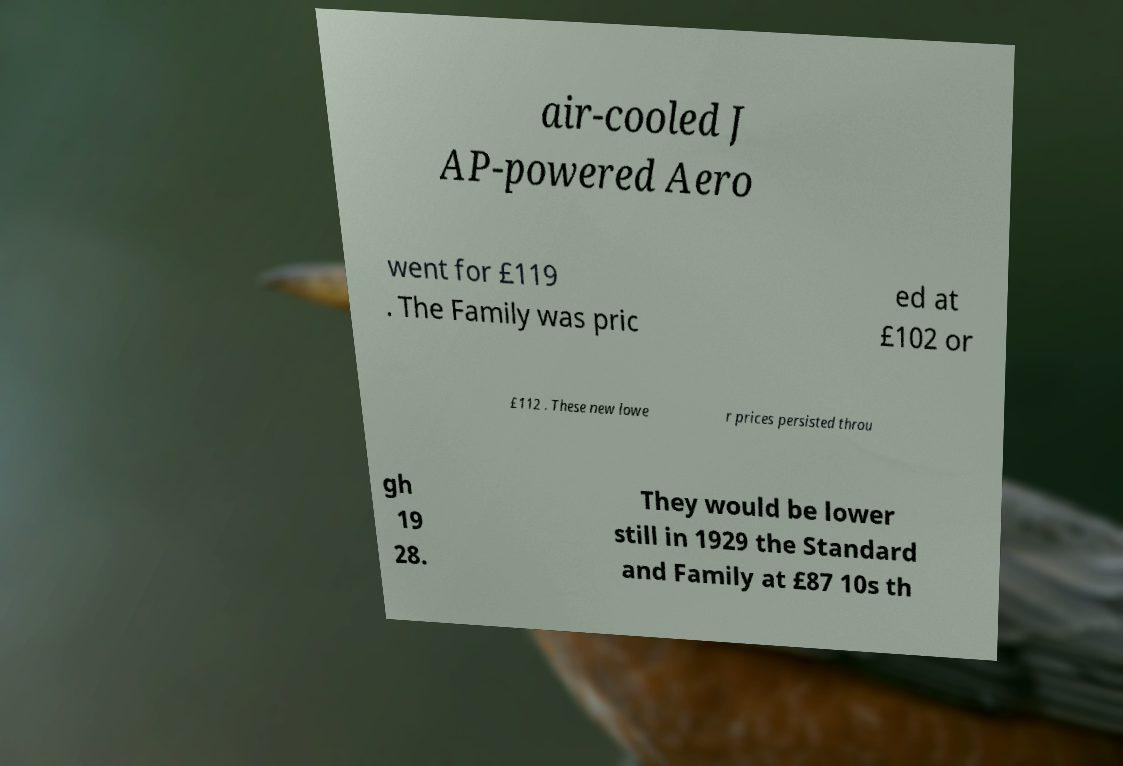Can you read and provide the text displayed in the image?This photo seems to have some interesting text. Can you extract and type it out for me? air-cooled J AP-powered Aero went for £119 . The Family was pric ed at £102 or £112 . These new lowe r prices persisted throu gh 19 28. They would be lower still in 1929 the Standard and Family at £87 10s th 